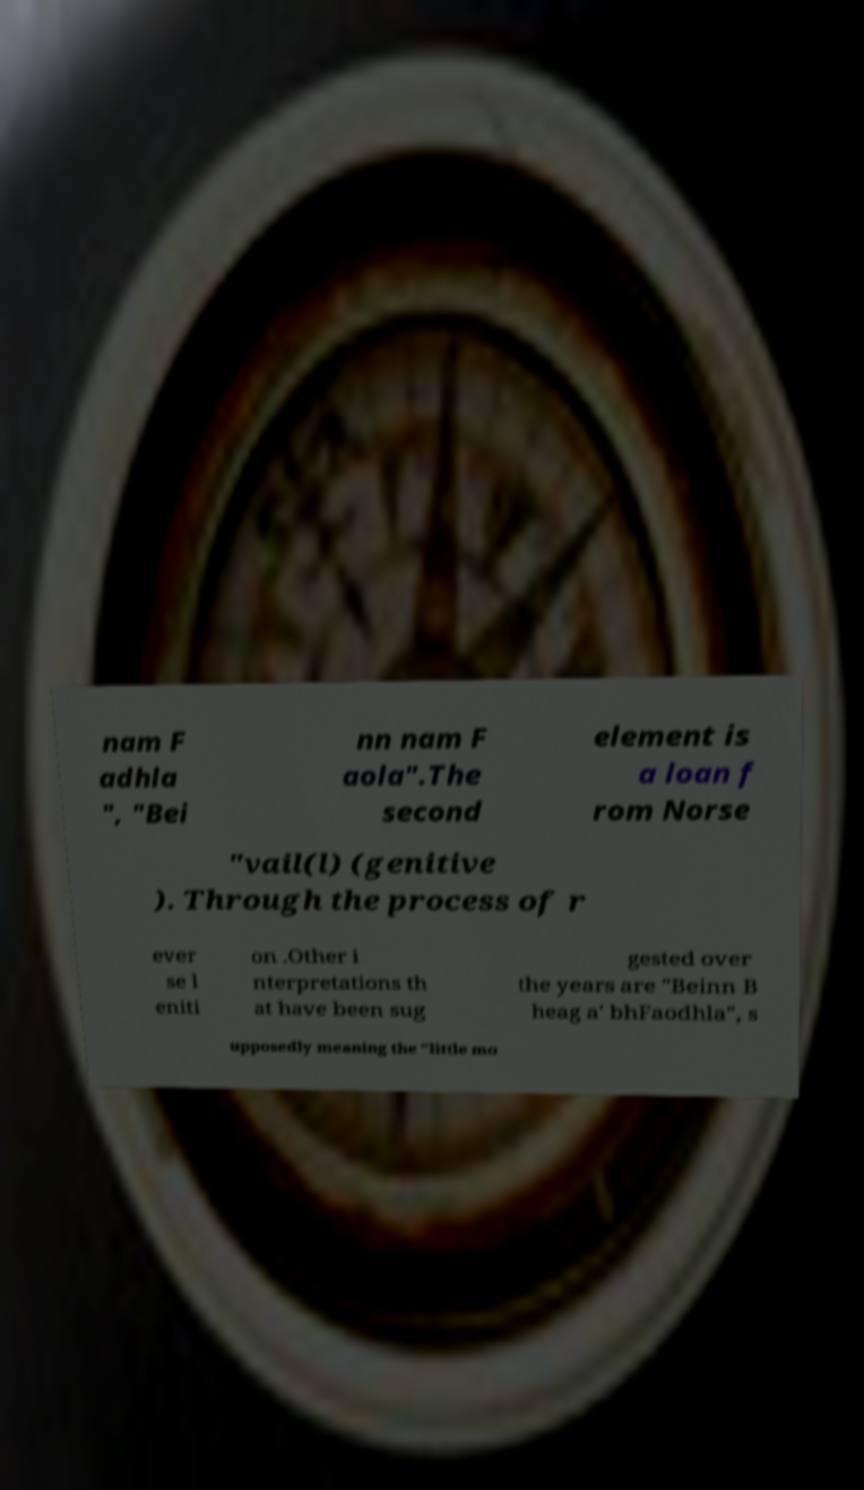Please read and relay the text visible in this image. What does it say? nam F adhla ", "Bei nn nam F aola".The second element is a loan f rom Norse "vail(l) (genitive ). Through the process of r ever se l eniti on .Other i nterpretations th at have been sug gested over the years are "Beinn B heag a' bhFaodhla", s upposedly meaning the "little mo 